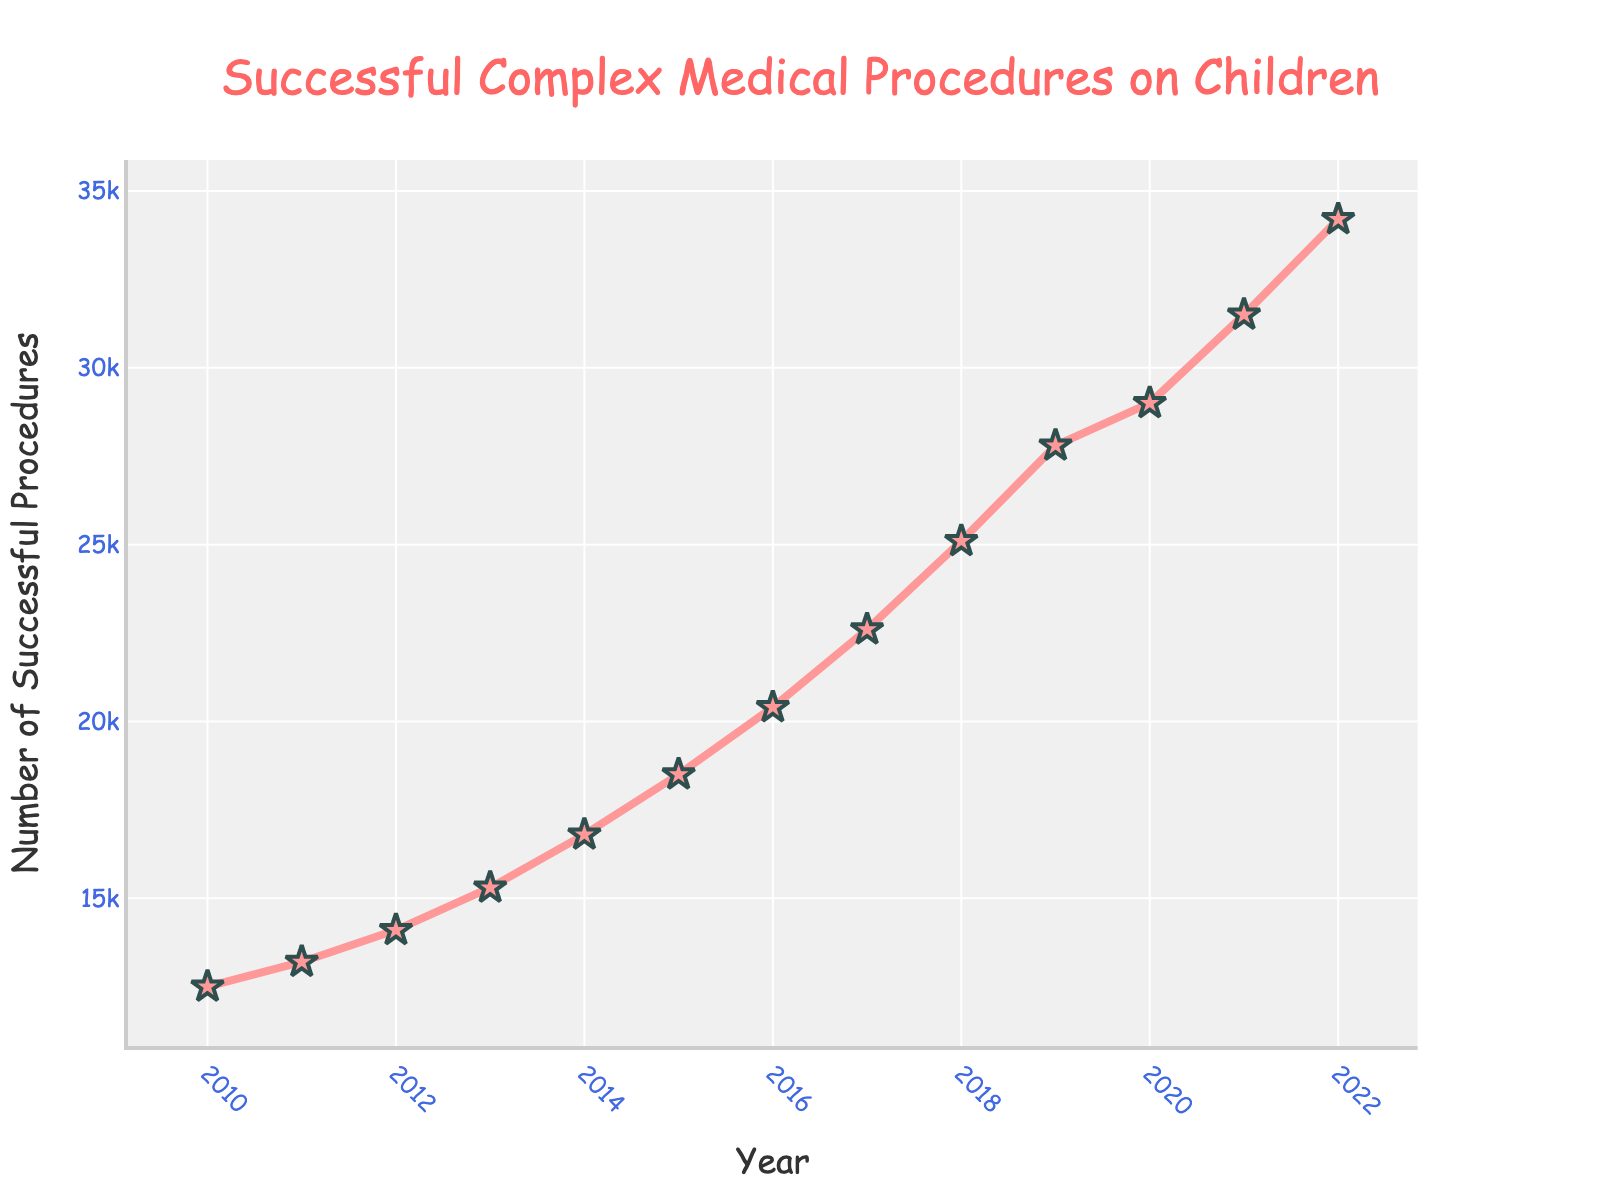How many successful complex medical procedures were performed on children in 2013? Look at the plot in the year 2013 and read off the corresponding number of successful procedures. The value is clearly marked beside the point.
Answer: 15,300 What was the increase in the number of successful procedures from 2018 to 2019? Identify the number of successful procedures in 2018 and 2019 from the plot and then subtract the 2018 value from the 2019 value. The values are 25,100 for 2018 and 27,800 for 2019, so the increase is 27,800 - 25,100.
Answer: 2,700 Which year had the highest number of successful complex medical procedures? Examine the plot for the highest point, which corresponds to the maximum number of successful procedures. The year associated with this point is 2022.
Answer: 2022 What is the average number of successful procedures from 2010 to 2012? Add the number of successful procedures for the years 2010, 2011, and 2012, and then divide by 3. The values are 12,500, 13,200, and 14,100 respectively. So, (12,500 + 13,200 + 14,100) / 3
Answer: 13,267 How does the number of successful procedures in 2015 compare to 2020? Compare the values for 2015 and 2020 from the plot. The number of successful procedures in 2015 is 18,500 and in 2020 is 29,000. Check which is higher or if they are equal.
Answer: 2020 has more By how much did the number of successful procedures increase from 2010 to 2022? Subtract the number of successful procedures in 2010 from the number in 2022. The values are 12,500 for 2010 and 34,200 for 2022. So, 34,200 - 12,500.
Answer: 21,700 What is the overall trend in the number of successful procedures from 2010 to 2022? Observe the general direction of the plot from 2010 to 2022. The line consistently rises, indicating an increase in successful procedures over these years.
Answer: Increasing What was the smallest increase in successful procedures between consecutive years? Calculate the difference between successful procedures for each pair of consecutive years from the plot and identify the smallest one. For example, from 2010 to 2011 it is 13,200 - 12,500 = 700, and similarly for other years.
Answer: 700 